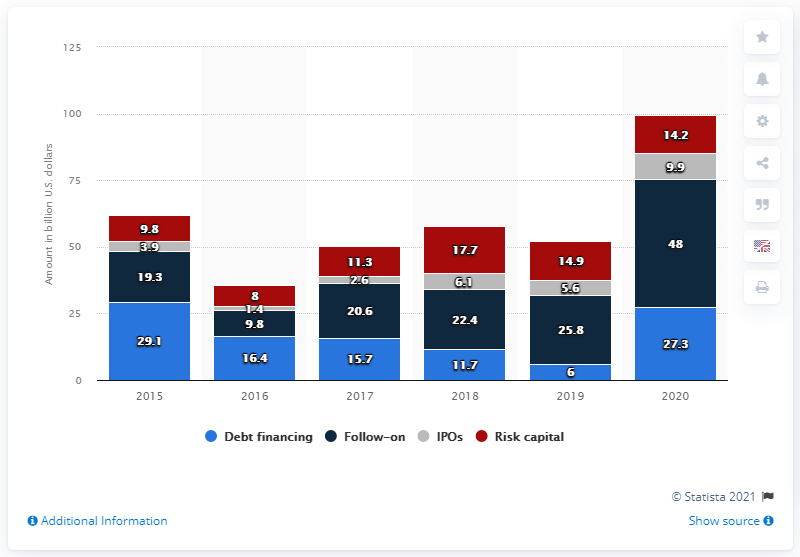Give some essential details in this illustration. The average of initial public offerings (IPOs) is approximately 4.9 billion U.S. dollars. In 2020, U.S. biotech companies received a total of $14.2 billion in risk capital. In 2020, U.S. biotech companies raised a significant amount of capital through initial public offerings (IPOs). Specifically, they raised 14.2... The maximum amount of financing for the follow-on offering is 48 billion U.S. dollars. 